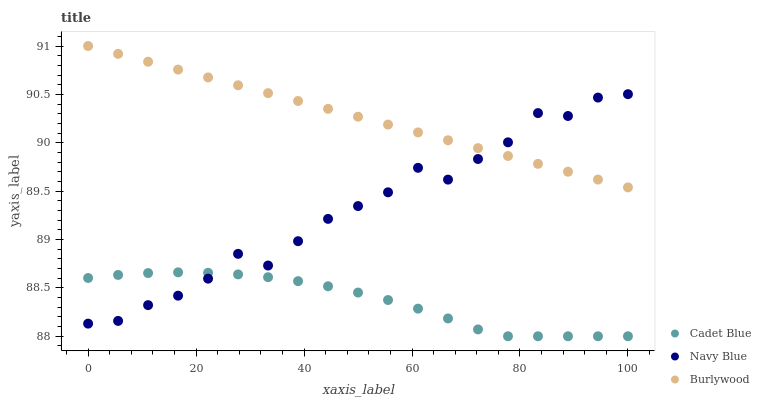Does Cadet Blue have the minimum area under the curve?
Answer yes or no. Yes. Does Burlywood have the maximum area under the curve?
Answer yes or no. Yes. Does Navy Blue have the minimum area under the curve?
Answer yes or no. No. Does Navy Blue have the maximum area under the curve?
Answer yes or no. No. Is Burlywood the smoothest?
Answer yes or no. Yes. Is Navy Blue the roughest?
Answer yes or no. Yes. Is Cadet Blue the smoothest?
Answer yes or no. No. Is Cadet Blue the roughest?
Answer yes or no. No. Does Cadet Blue have the lowest value?
Answer yes or no. Yes. Does Navy Blue have the lowest value?
Answer yes or no. No. Does Burlywood have the highest value?
Answer yes or no. Yes. Does Navy Blue have the highest value?
Answer yes or no. No. Is Cadet Blue less than Burlywood?
Answer yes or no. Yes. Is Burlywood greater than Cadet Blue?
Answer yes or no. Yes. Does Burlywood intersect Navy Blue?
Answer yes or no. Yes. Is Burlywood less than Navy Blue?
Answer yes or no. No. Is Burlywood greater than Navy Blue?
Answer yes or no. No. Does Cadet Blue intersect Burlywood?
Answer yes or no. No. 